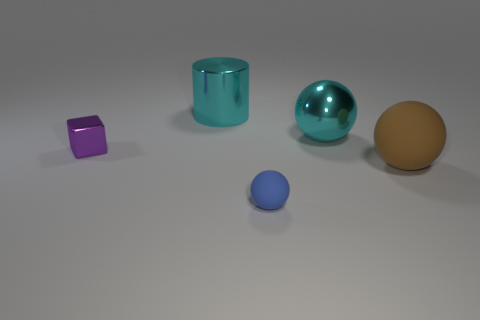Subtract all yellow spheres. Subtract all red cylinders. How many spheres are left? 3 Add 1 small gray blocks. How many objects exist? 6 Subtract all balls. How many objects are left? 2 Add 3 tiny blue spheres. How many tiny blue spheres exist? 4 Subtract 0 red balls. How many objects are left? 5 Subtract all cylinders. Subtract all large cyan metallic cylinders. How many objects are left? 3 Add 4 purple objects. How many purple objects are left? 5 